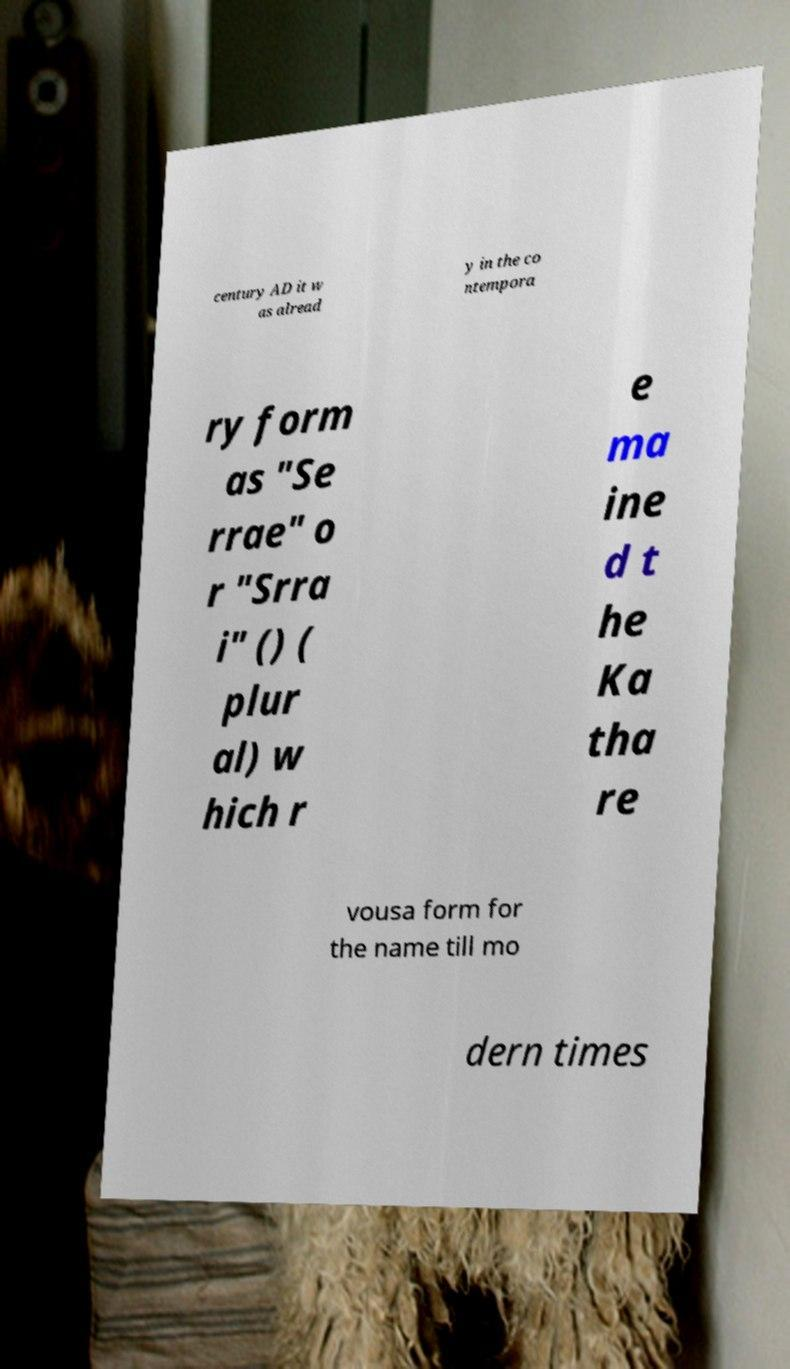Could you extract and type out the text from this image? century AD it w as alread y in the co ntempora ry form as "Se rrae" o r "Srra i" () ( plur al) w hich r e ma ine d t he Ka tha re vousa form for the name till mo dern times 